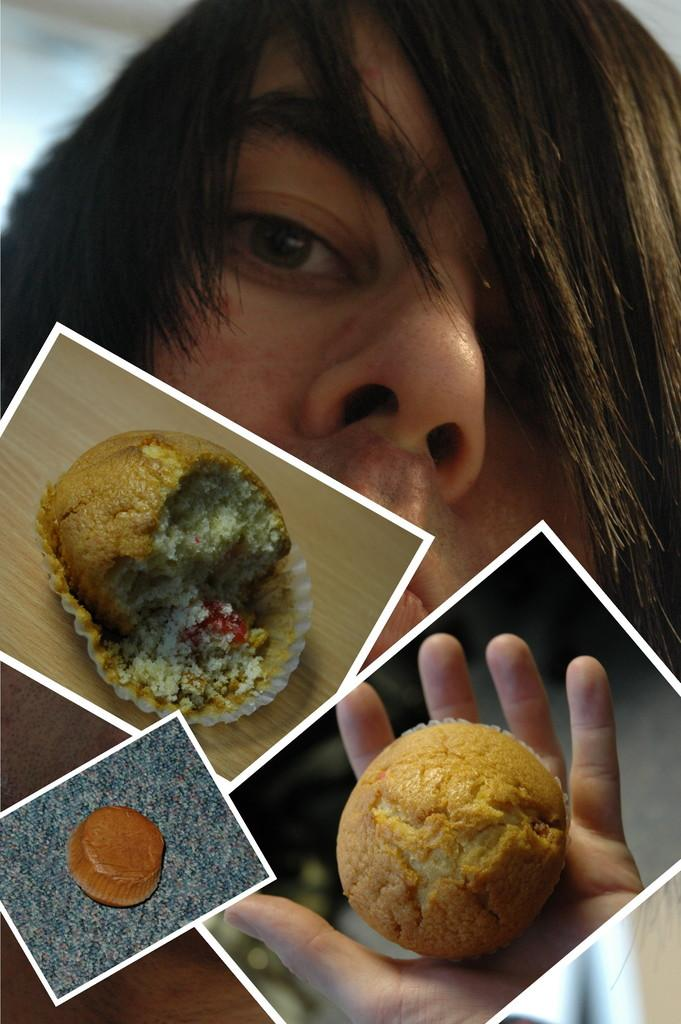What is the main subject of the image? The main subject of the image is a picture of a person. What else can be seen in the image besides the person? There are pictures of food items in the image. What type of pen is being used to draw the butter in the image? There is no pen or butter present in the image; it only contains pictures of a person and food items. 